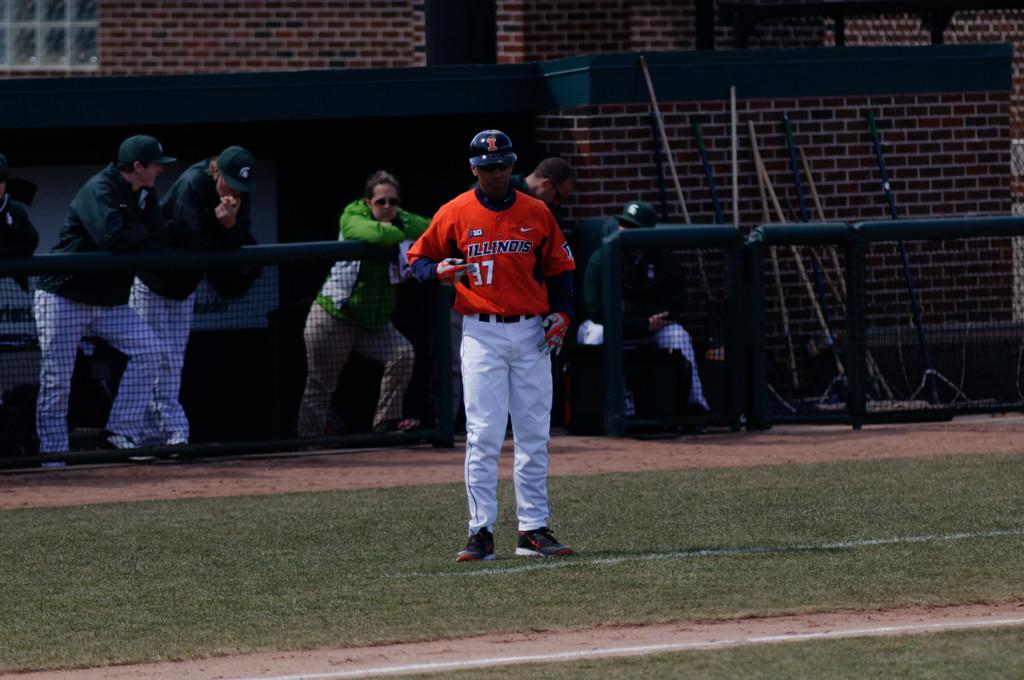<image>
Share a concise interpretation of the image provided. An Illinois baseball player wearing number 37 stands in front of a fence with other players leaning on it. 